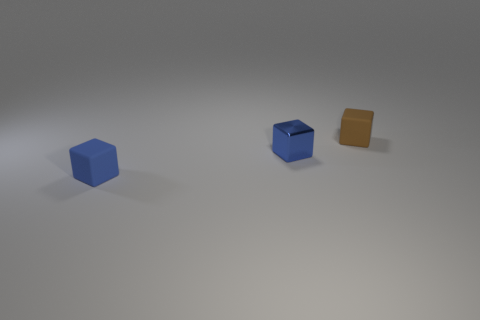How does the lighting in the image affect the perception of the objects' materials? The lighting in the image casts subtle shadows and highlights that accentuate the textures and materials of the objects. The blue and metallic cubes reflect light differently, suggesting that one is matte and the other has a glossy, reflective surface. The brown object, with its diffuse shadows, appears to have a rougher, more absorbent surface that doesn't reflect as much light. 